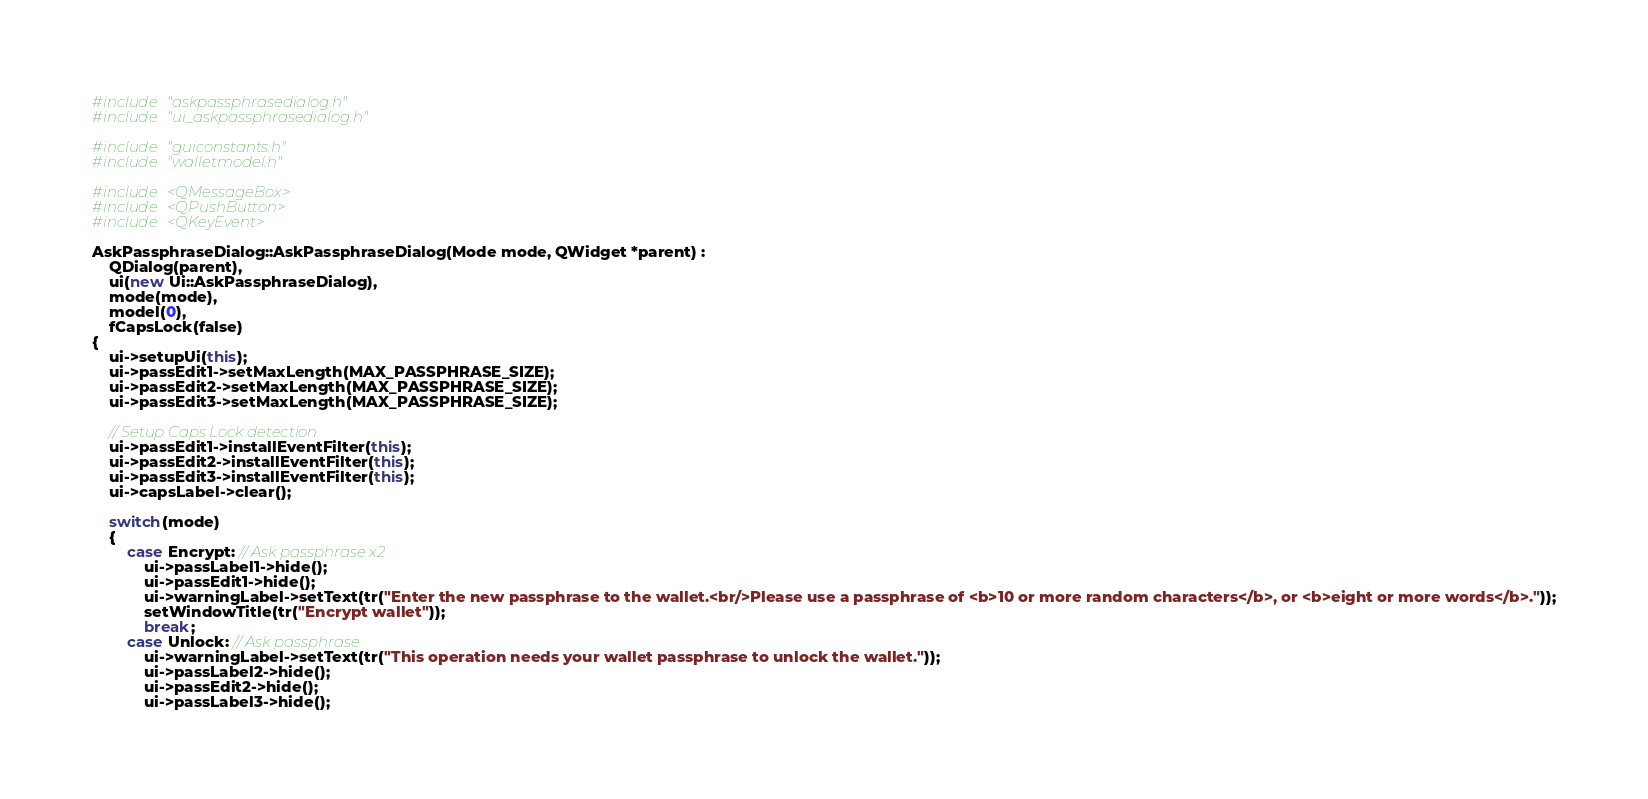<code> <loc_0><loc_0><loc_500><loc_500><_C++_>#include "askpassphrasedialog.h"
#include "ui_askpassphrasedialog.h"

#include "guiconstants.h"
#include "walletmodel.h"

#include <QMessageBox>
#include <QPushButton>
#include <QKeyEvent>

AskPassphraseDialog::AskPassphraseDialog(Mode mode, QWidget *parent) :
    QDialog(parent),
    ui(new Ui::AskPassphraseDialog),
    mode(mode),
    model(0),
    fCapsLock(false)
{
    ui->setupUi(this);
    ui->passEdit1->setMaxLength(MAX_PASSPHRASE_SIZE);
    ui->passEdit2->setMaxLength(MAX_PASSPHRASE_SIZE);
    ui->passEdit3->setMaxLength(MAX_PASSPHRASE_SIZE);
    
    // Setup Caps Lock detection.
    ui->passEdit1->installEventFilter(this);
    ui->passEdit2->installEventFilter(this);
    ui->passEdit3->installEventFilter(this);
    ui->capsLabel->clear();

    switch(mode)
    {
        case Encrypt: // Ask passphrase x2
            ui->passLabel1->hide();
            ui->passEdit1->hide();
            ui->warningLabel->setText(tr("Enter the new passphrase to the wallet.<br/>Please use a passphrase of <b>10 or more random characters</b>, or <b>eight or more words</b>."));
            setWindowTitle(tr("Encrypt wallet"));
            break;
        case Unlock: // Ask passphrase
            ui->warningLabel->setText(tr("This operation needs your wallet passphrase to unlock the wallet."));
            ui->passLabel2->hide();
            ui->passEdit2->hide();
            ui->passLabel3->hide();</code> 